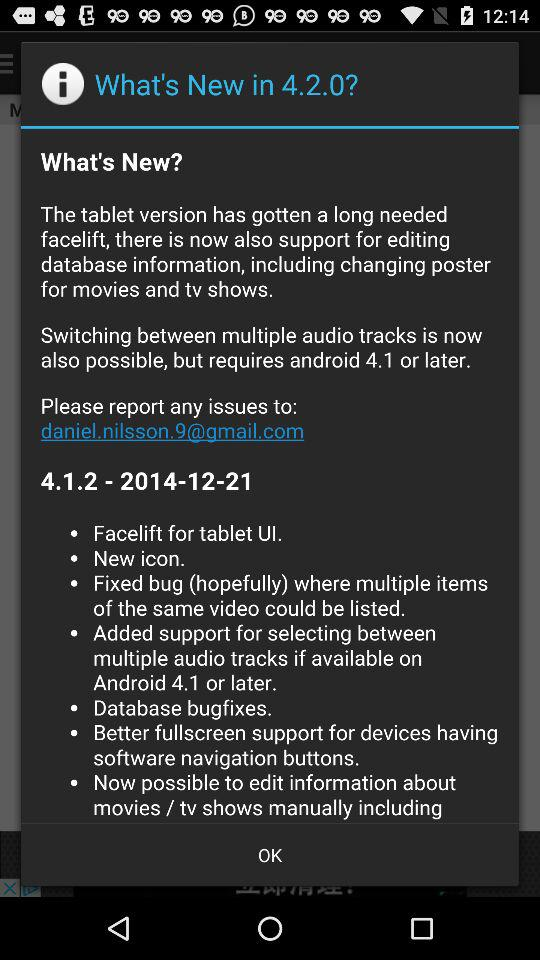What is the minimum Android version required to use this app?
Answer the question using a single word or phrase. Android 4.1 or later 